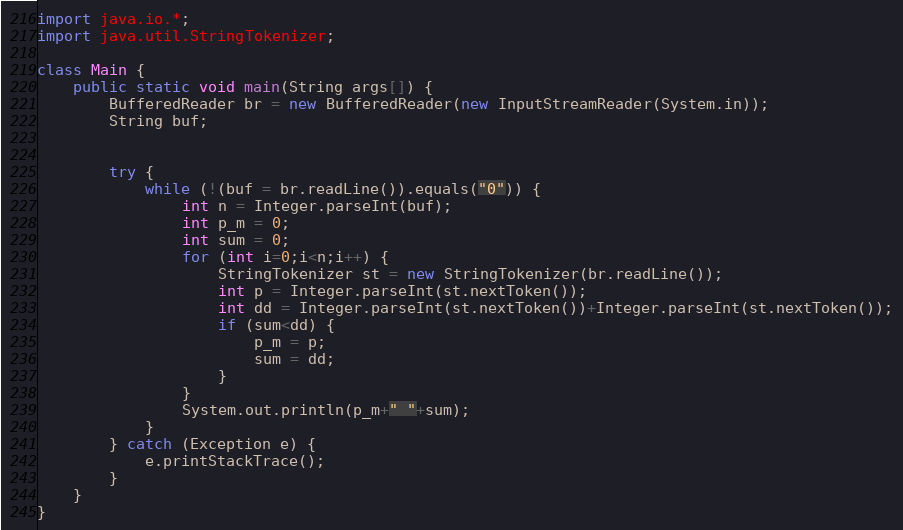Convert code to text. <code><loc_0><loc_0><loc_500><loc_500><_Java_>import java.io.*;
import java.util.StringTokenizer;

class Main {
	public static void main(String args[]) {
		BufferedReader br = new BufferedReader(new InputStreamReader(System.in));
		String buf;


		try {
			while (!(buf = br.readLine()).equals("0")) {
				int n = Integer.parseInt(buf);
				int p_m = 0;
				int sum = 0;
				for (int i=0;i<n;i++) {
					StringTokenizer st = new StringTokenizer(br.readLine());
					int p = Integer.parseInt(st.nextToken());
					int dd = Integer.parseInt(st.nextToken())+Integer.parseInt(st.nextToken());
					if (sum<dd) {
						p_m = p;
						sum = dd;
					}
				}
				System.out.println(p_m+" "+sum);
			}
		} catch (Exception e) {
			e.printStackTrace();
		}
	}
}</code> 